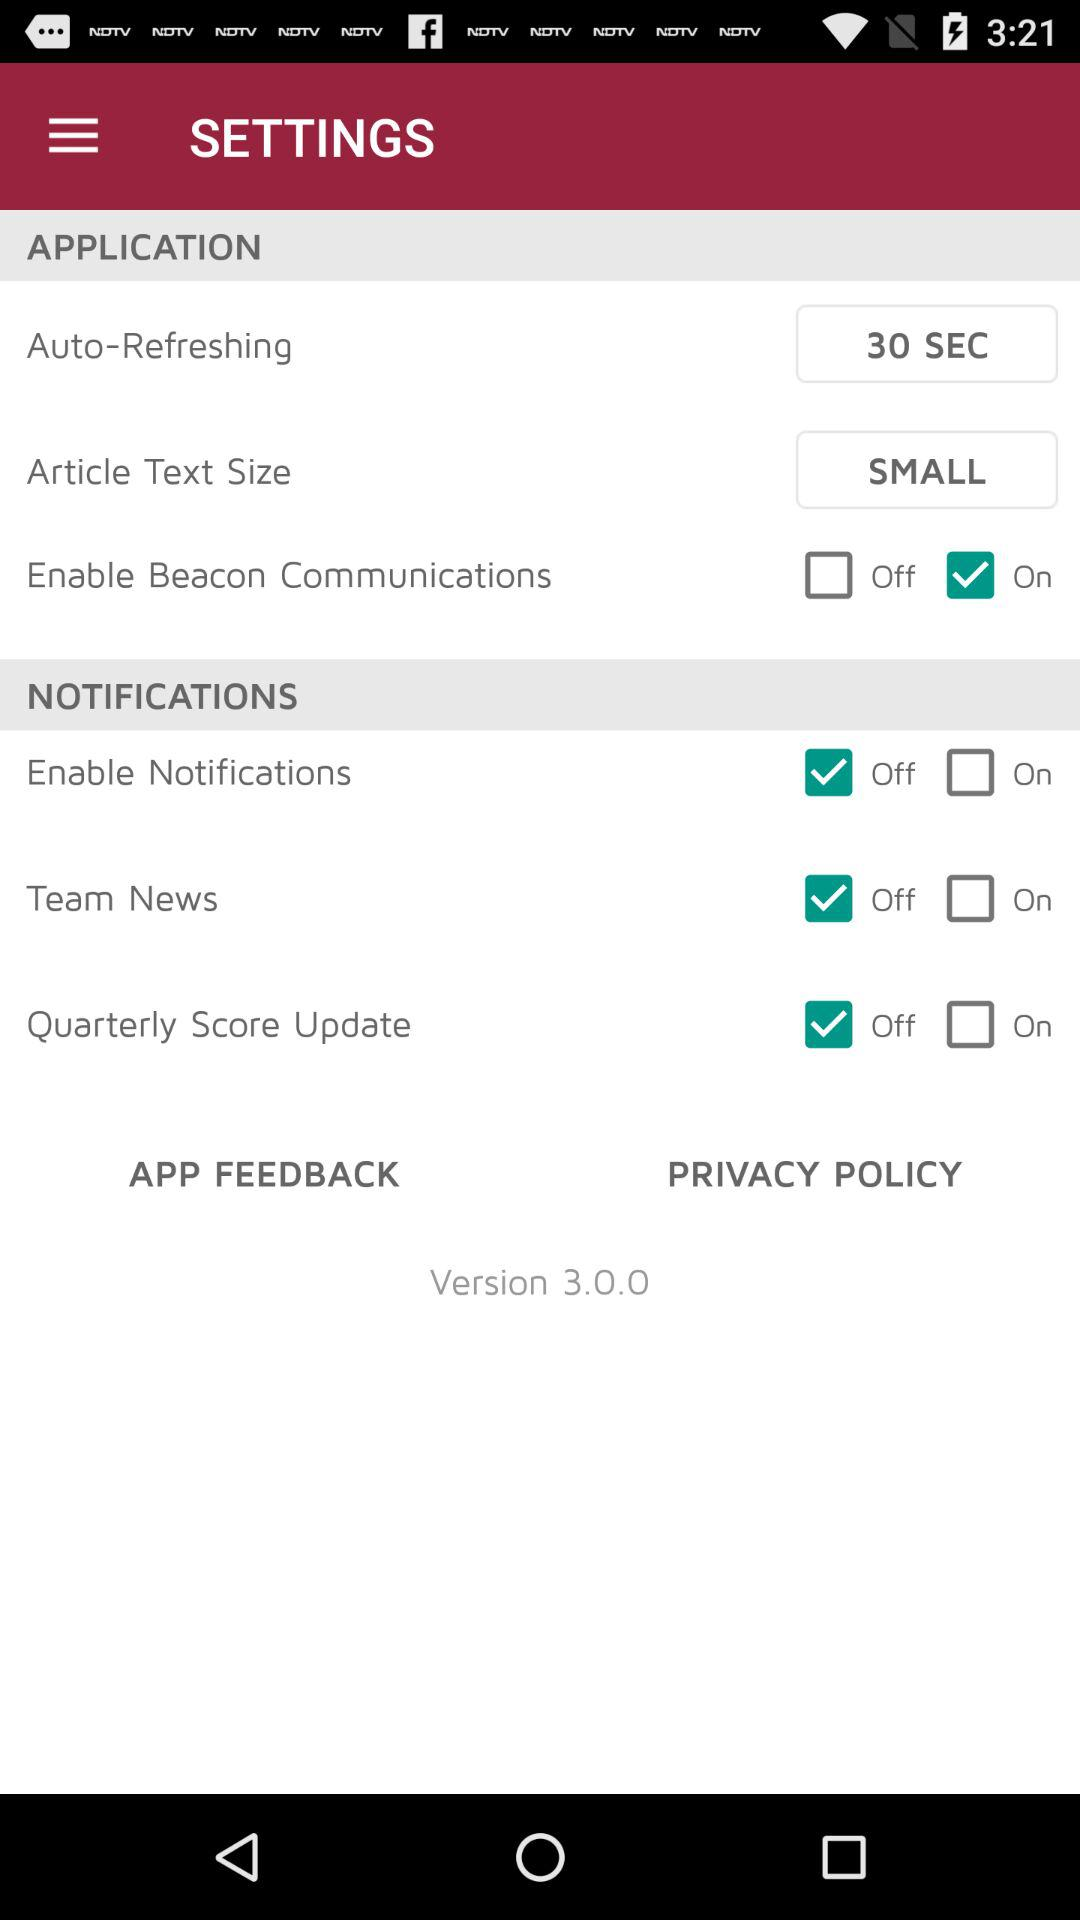What is the auto-refresh duration? The auto-refresh duration is 30 seconds. 